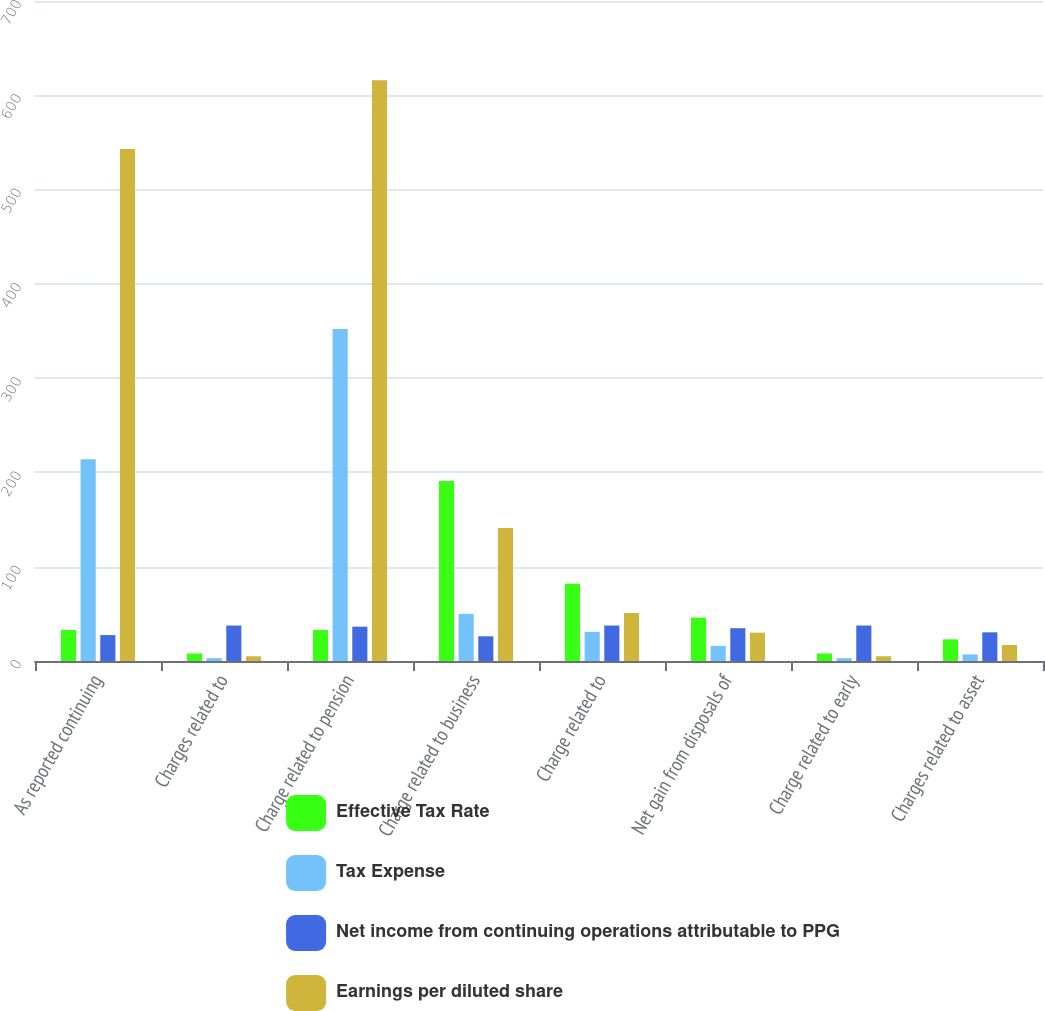Convert chart to OTSL. <chart><loc_0><loc_0><loc_500><loc_500><stacked_bar_chart><ecel><fcel>As reported continuing<fcel>Charges related to<fcel>Charge related to pension<fcel>Charge related to business<fcel>Charge related to<fcel>Net gain from disposals of<fcel>Charge related to early<fcel>Charges related to asset<nl><fcel>Effective Tax Rate<fcel>32.9<fcel>8<fcel>32.9<fcel>191<fcel>82<fcel>46<fcel>8<fcel>23<nl><fcel>Tax Expense<fcel>214<fcel>3<fcel>352<fcel>50<fcel>31<fcel>16<fcel>3<fcel>7<nl><fcel>Net income from continuing operations attributable to PPG<fcel>27.5<fcel>37.6<fcel>36.4<fcel>26.2<fcel>37.6<fcel>34.8<fcel>37.6<fcel>30.4<nl><fcel>Earnings per diluted share<fcel>543<fcel>5<fcel>616<fcel>141<fcel>51<fcel>30<fcel>5<fcel>17<nl></chart> 